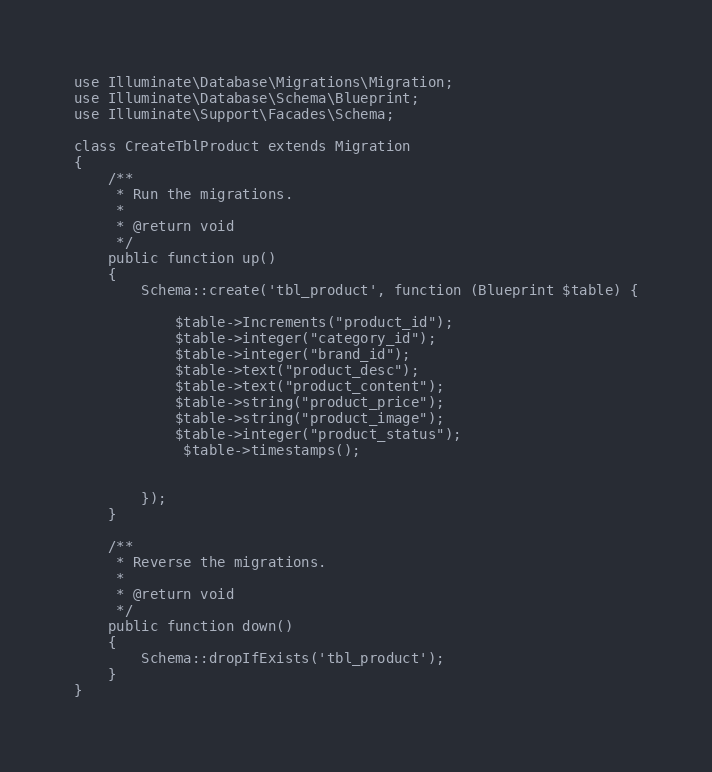Convert code to text. <code><loc_0><loc_0><loc_500><loc_500><_PHP_>
use Illuminate\Database\Migrations\Migration;
use Illuminate\Database\Schema\Blueprint;
use Illuminate\Support\Facades\Schema;

class CreateTblProduct extends Migration
{
    /**
     * Run the migrations.
     *
     * @return void
     */
    public function up()
    {
        Schema::create('tbl_product', function (Blueprint $table) {
        
            $table->Increments("product_id");
            $table->integer("category_id");
            $table->integer("brand_id");
            $table->text("product_desc");
            $table->text("product_content");
            $table->string("product_price");
            $table->string("product_image");
            $table->integer("product_status");
             $table->timestamps();


        });
    }

    /**
     * Reverse the migrations.
     *
     * @return void
     */
    public function down()
    {
        Schema::dropIfExists('tbl_product');
    }
}
</code> 